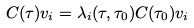<formula> <loc_0><loc_0><loc_500><loc_500>C ( \tau ) v _ { i } = \lambda _ { i } ( \tau , \tau _ { 0 } ) C ( \tau _ { 0 } ) v _ { i }</formula> 